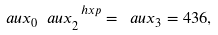<formula> <loc_0><loc_0><loc_500><loc_500>\ a u x _ { 0 } \ a u x _ { 2 } ^ { \ h x p } = \ a u x _ { 3 } = 4 3 6 ,</formula> 